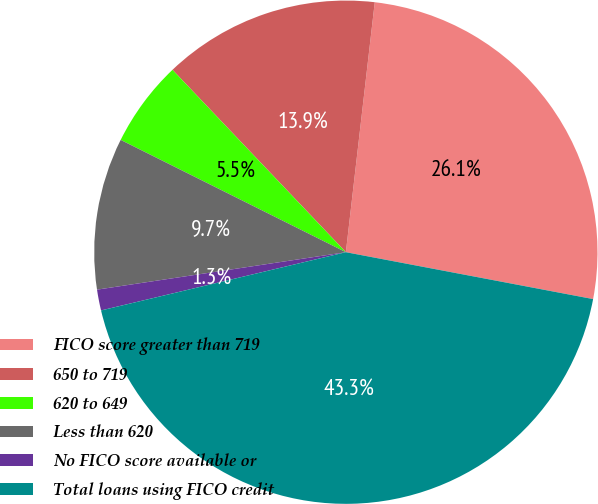Convert chart to OTSL. <chart><loc_0><loc_0><loc_500><loc_500><pie_chart><fcel>FICO score greater than 719<fcel>650 to 719<fcel>620 to 649<fcel>Less than 620<fcel>No FICO score available or<fcel>Total loans using FICO credit<nl><fcel>26.15%<fcel>13.93%<fcel>5.54%<fcel>9.74%<fcel>1.34%<fcel>43.3%<nl></chart> 